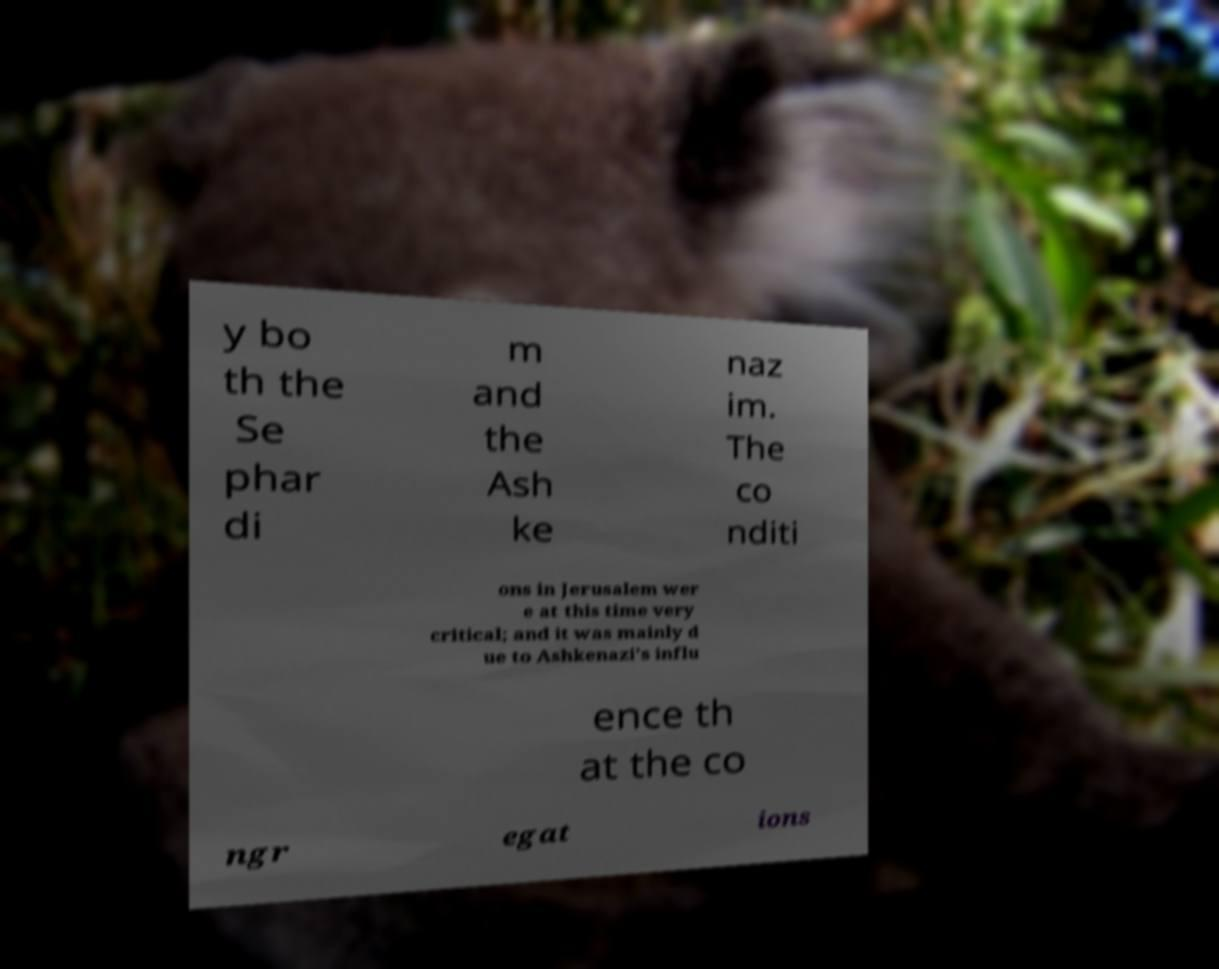I need the written content from this picture converted into text. Can you do that? y bo th the Se phar di m and the Ash ke naz im. The co nditi ons in Jerusalem wer e at this time very critical; and it was mainly d ue to Ashkenazi's influ ence th at the co ngr egat ions 